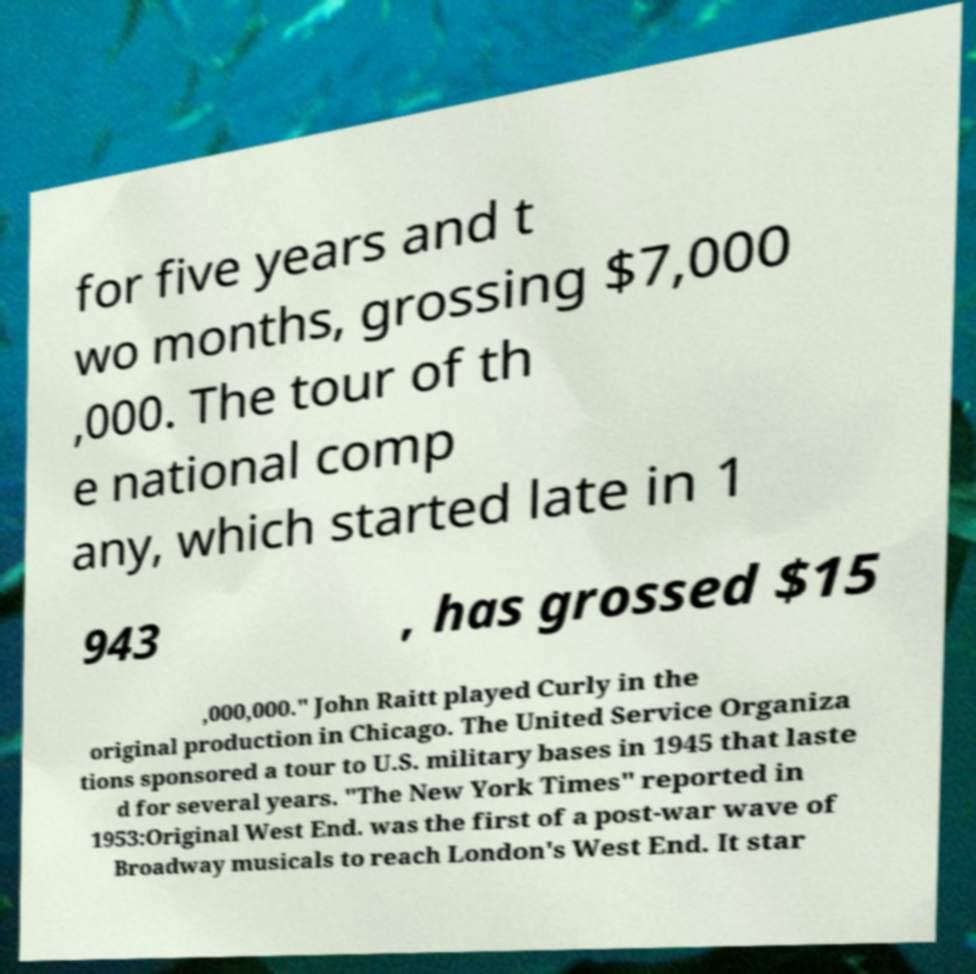For documentation purposes, I need the text within this image transcribed. Could you provide that? for five years and t wo months, grossing $7,000 ,000. The tour of th e national comp any, which started late in 1 943 , has grossed $15 ,000,000." John Raitt played Curly in the original production in Chicago. The United Service Organiza tions sponsored a tour to U.S. military bases in 1945 that laste d for several years. "The New York Times" reported in 1953:Original West End. was the first of a post-war wave of Broadway musicals to reach London's West End. It star 